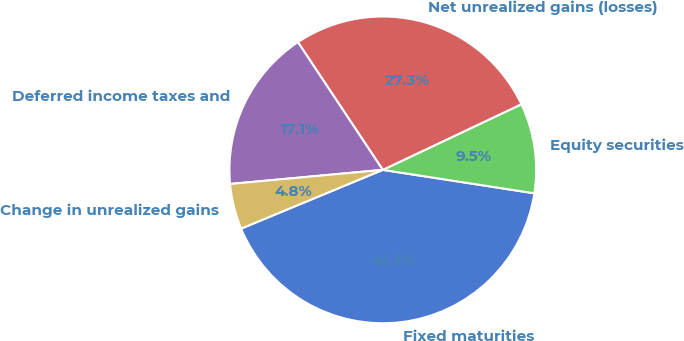Convert chart to OTSL. <chart><loc_0><loc_0><loc_500><loc_500><pie_chart><fcel>Fixed maturities<fcel>Equity securities<fcel>Net unrealized gains (losses)<fcel>Deferred income taxes and<fcel>Change in unrealized gains<nl><fcel>41.3%<fcel>9.48%<fcel>27.3%<fcel>17.13%<fcel>4.79%<nl></chart> 